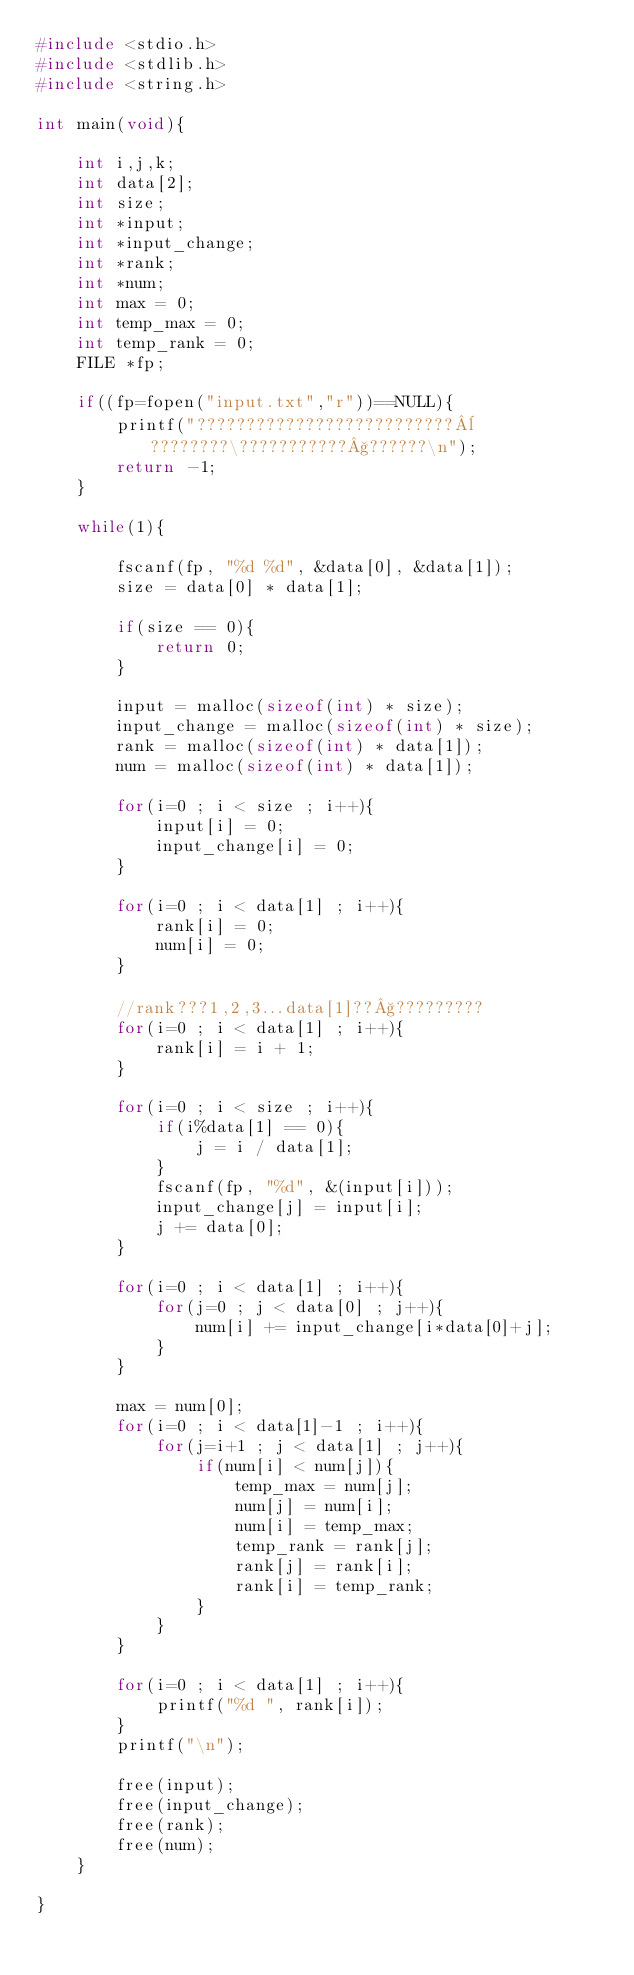Convert code to text. <code><loc_0><loc_0><loc_500><loc_500><_C_>#include <stdio.h>
#include <stdlib.h>
#include <string.h>

int main(void){

	int i,j,k;
	int data[2];
	int size;
	int *input;
	int *input_change;
	int *rank;
	int *num;
	int max = 0;
	int temp_max = 0;
	int temp_rank = 0;
	FILE *fp;
	
	if((fp=fopen("input.txt","r"))==NULL){
		printf("??????????????????????????¨????????\???????????§??????\n");
		return -1;
	}
	
	while(1){
	
		fscanf(fp, "%d %d", &data[0], &data[1]);		
		size = data[0] * data[1];
		
		if(size == 0){
			return 0;
		}
	
		input = malloc(sizeof(int) * size);
		input_change = malloc(sizeof(int) * size);
		rank = malloc(sizeof(int) * data[1]);
		num = malloc(sizeof(int) * data[1]);
		
		for(i=0 ; i < size ; i++){
			input[i] = 0;
			input_change[i] = 0;
		}
		
		for(i=0 ; i < data[1] ; i++){
			rank[i] = 0;
			num[i] = 0;
 		}
 		
 		//rank???1,2,3...data[1]??§?????????
		for(i=0 ; i < data[1] ; i++){
			rank[i] = i + 1;
		}
	
		for(i=0 ; i < size ; i++){
			if(i%data[1] == 0){
				j = i / data[1];
			}
			fscanf(fp, "%d", &(input[i]));
			input_change[j] = input[i];
			j += data[0];
		}
		
		for(i=0 ; i < data[1] ; i++){
			for(j=0 ; j < data[0] ; j++){
				num[i] += input_change[i*data[0]+j];
			}
		}
	
		max = num[0];
		for(i=0 ; i < data[1]-1 ; i++){
			for(j=i+1 ; j < data[1] ; j++){
				if(num[i] < num[j]){
					temp_max = num[j];
					num[j] = num[i];
					num[i] = temp_max;
					temp_rank = rank[j];
					rank[j] = rank[i];
					rank[i] = temp_rank;
				}
			}
		}	

		for(i=0 ; i < data[1] ; i++){
			printf("%d ", rank[i]);
		}	
		printf("\n");
		
		free(input);
		free(input_change);
		free(rank);
		free(num);
	}
	
}</code> 